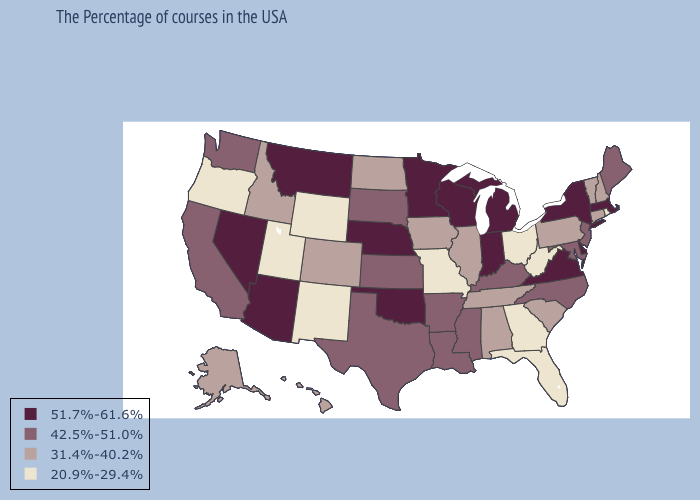What is the highest value in the West ?
Write a very short answer. 51.7%-61.6%. Among the states that border Colorado , does Utah have the lowest value?
Quick response, please. Yes. Name the states that have a value in the range 20.9%-29.4%?
Concise answer only. Rhode Island, West Virginia, Ohio, Florida, Georgia, Missouri, Wyoming, New Mexico, Utah, Oregon. What is the lowest value in the MidWest?
Short answer required. 20.9%-29.4%. Does the map have missing data?
Short answer required. No. Among the states that border New Mexico , does Arizona have the lowest value?
Give a very brief answer. No. What is the value of Missouri?
Short answer required. 20.9%-29.4%. Name the states that have a value in the range 42.5%-51.0%?
Keep it brief. Maine, New Jersey, Maryland, North Carolina, Kentucky, Mississippi, Louisiana, Arkansas, Kansas, Texas, South Dakota, California, Washington. What is the value of New Jersey?
Be succinct. 42.5%-51.0%. Does the map have missing data?
Short answer required. No. Does the first symbol in the legend represent the smallest category?
Keep it brief. No. Does Colorado have the highest value in the West?
Be succinct. No. Does Montana have the highest value in the West?
Write a very short answer. Yes. Is the legend a continuous bar?
Keep it brief. No. Does the first symbol in the legend represent the smallest category?
Be succinct. No. 